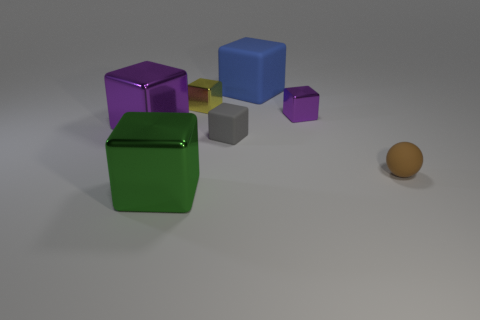Subtract all green cubes. How many cubes are left? 5 Subtract all tiny purple cubes. How many cubes are left? 5 Subtract all green balls. Subtract all red cylinders. How many balls are left? 1 Add 1 blocks. How many objects exist? 8 Subtract all spheres. How many objects are left? 6 Add 2 purple blocks. How many purple blocks are left? 4 Add 7 big green objects. How many big green objects exist? 8 Subtract 1 yellow blocks. How many objects are left? 6 Subtract all blue matte cubes. Subtract all tiny brown balls. How many objects are left? 5 